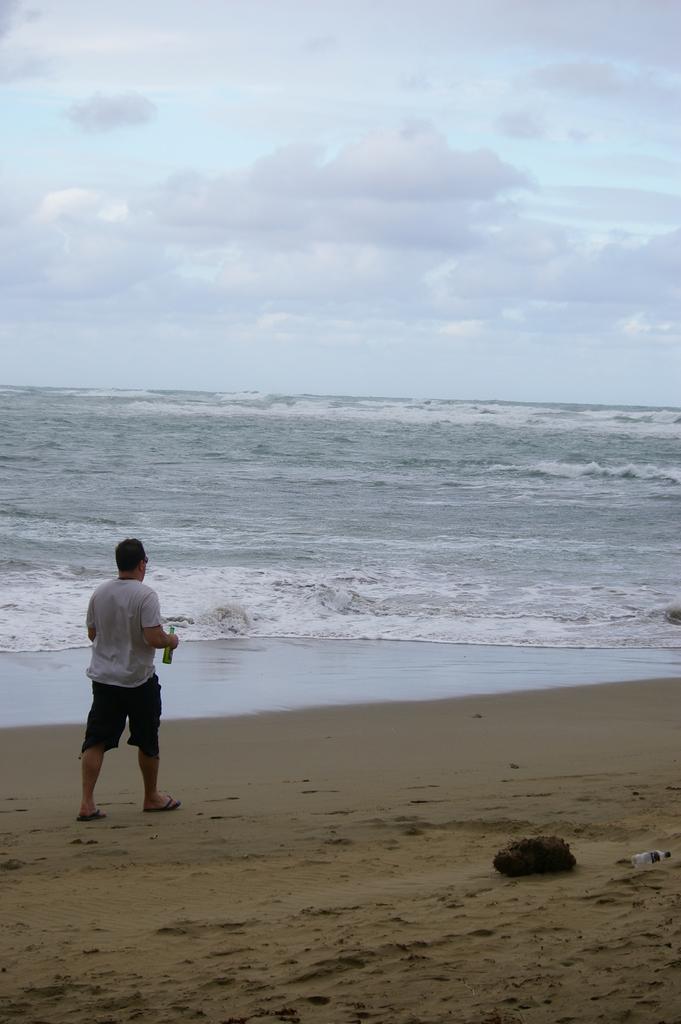In one or two sentences, can you explain what this image depicts? In this image I can see a man is standing on the ground and I can see he is holding a bottle. I can also he is wearing white t-shirt, black shorts and slippers. On the bottom right side of the image I can see a bottle and in the background I can see water, clouds and the sky. 